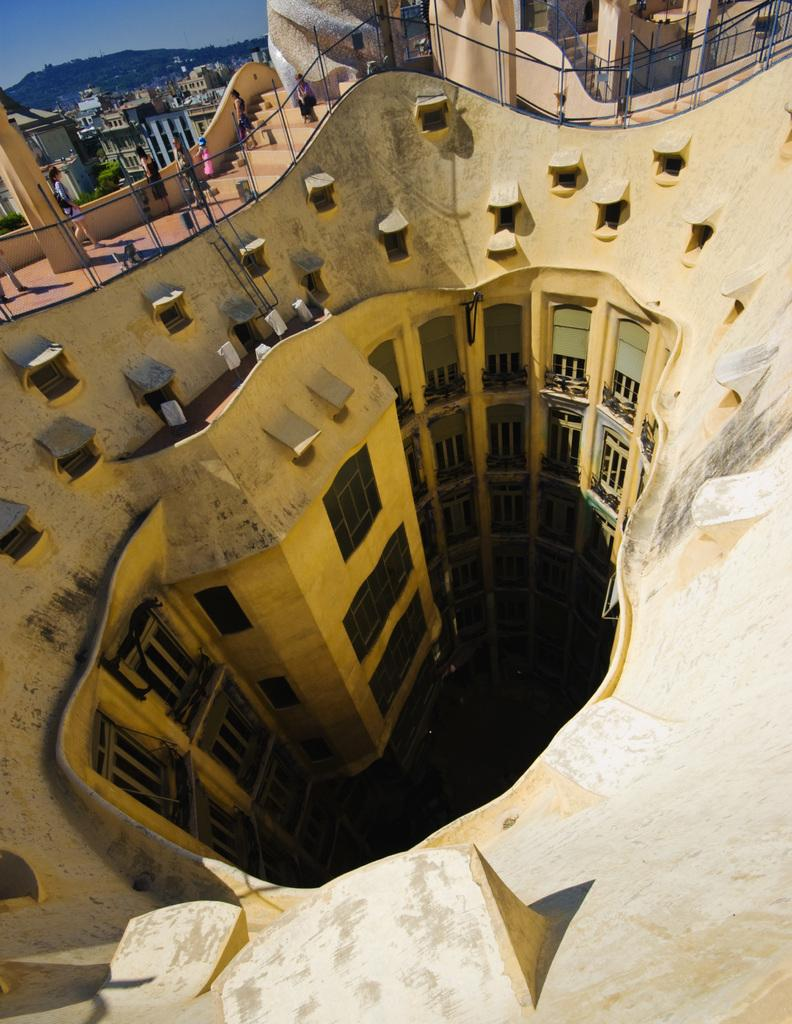What is the perspective of the image? The image shows a top view of a building. Can you describe any people or objects in the image? Yes, there are persons in the top left of the image. What color are the toes of the person in the image? There is no visible person's toes in the image, as it is a top view of a building. 